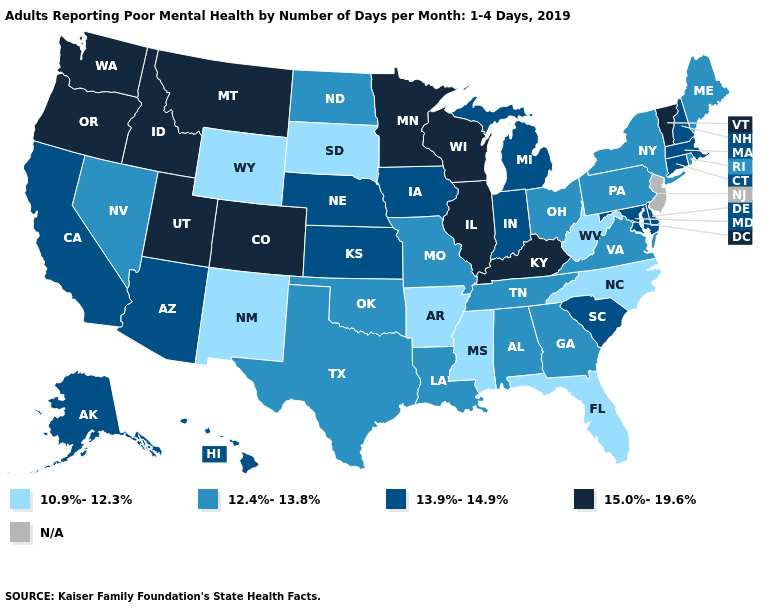Does Michigan have the lowest value in the USA?
Short answer required. No. How many symbols are there in the legend?
Answer briefly. 5. Name the states that have a value in the range 12.4%-13.8%?
Short answer required. Alabama, Georgia, Louisiana, Maine, Missouri, Nevada, New York, North Dakota, Ohio, Oklahoma, Pennsylvania, Rhode Island, Tennessee, Texas, Virginia. Name the states that have a value in the range 12.4%-13.8%?
Quick response, please. Alabama, Georgia, Louisiana, Maine, Missouri, Nevada, New York, North Dakota, Ohio, Oklahoma, Pennsylvania, Rhode Island, Tennessee, Texas, Virginia. Which states have the lowest value in the USA?
Be succinct. Arkansas, Florida, Mississippi, New Mexico, North Carolina, South Dakota, West Virginia, Wyoming. What is the lowest value in the West?
Be succinct. 10.9%-12.3%. What is the value of Missouri?
Short answer required. 12.4%-13.8%. What is the highest value in the South ?
Be succinct. 15.0%-19.6%. What is the highest value in the USA?
Concise answer only. 15.0%-19.6%. What is the value of Michigan?
Short answer required. 13.9%-14.9%. Which states have the lowest value in the USA?
Concise answer only. Arkansas, Florida, Mississippi, New Mexico, North Carolina, South Dakota, West Virginia, Wyoming. Does the map have missing data?
Give a very brief answer. Yes. Does North Dakota have the highest value in the USA?
Short answer required. No. Which states hav the highest value in the Northeast?
Concise answer only. Vermont. What is the highest value in states that border Minnesota?
Be succinct. 15.0%-19.6%. 